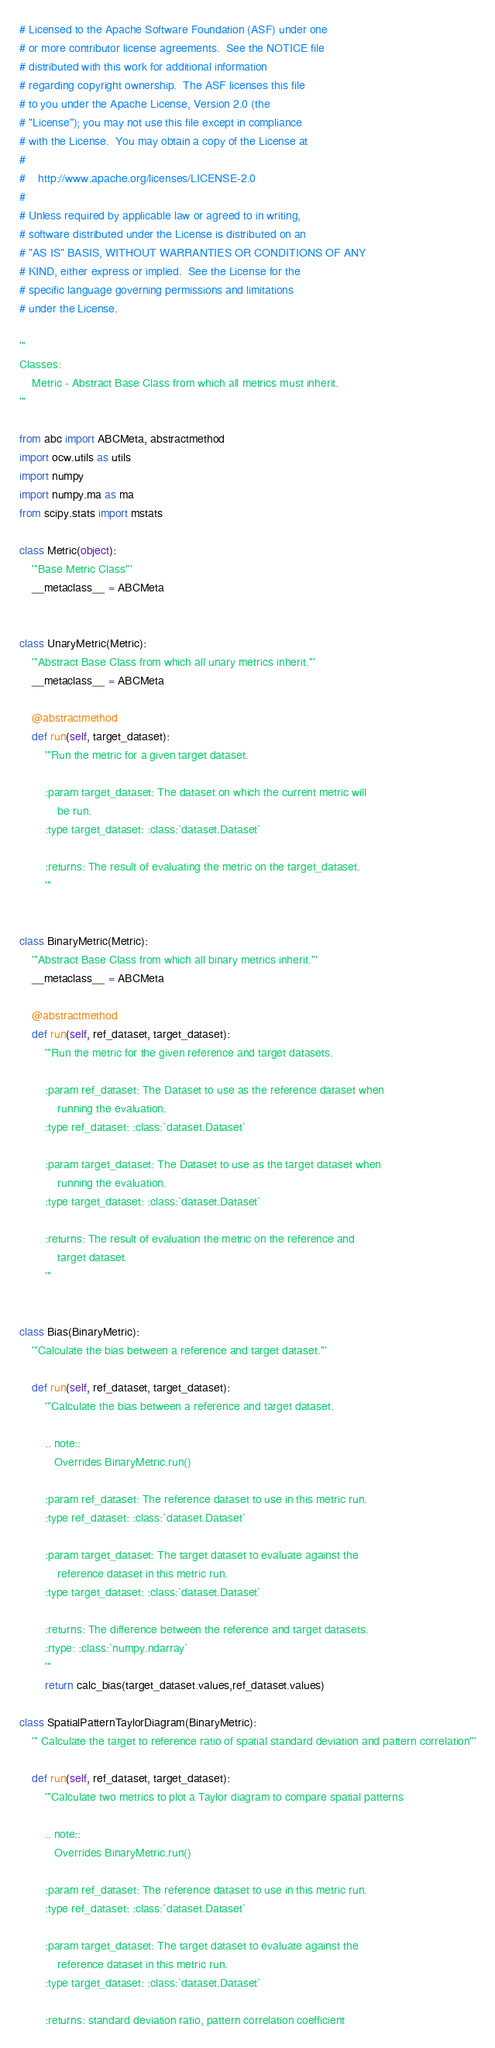Convert code to text. <code><loc_0><loc_0><loc_500><loc_500><_Python_># Licensed to the Apache Software Foundation (ASF) under one
# or more contributor license agreements.  See the NOTICE file
# distributed with this work for additional information
# regarding copyright ownership.  The ASF licenses this file
# to you under the Apache License, Version 2.0 (the
# "License"); you may not use this file except in compliance
# with the License.  You may obtain a copy of the License at
#
#    http://www.apache.org/licenses/LICENSE-2.0
#
# Unless required by applicable law or agreed to in writing,
# software distributed under the License is distributed on an
# "AS IS" BASIS, WITHOUT WARRANTIES OR CONDITIONS OF ANY
# KIND, either express or implied.  See the License for the
# specific language governing permissions and limitations
# under the License.

'''
Classes:
    Metric - Abstract Base Class from which all metrics must inherit.
'''

from abc import ABCMeta, abstractmethod
import ocw.utils as utils
import numpy
import numpy.ma as ma
from scipy.stats import mstats

class Metric(object):
    '''Base Metric Class'''
    __metaclass__ = ABCMeta


class UnaryMetric(Metric):
    '''Abstract Base Class from which all unary metrics inherit.'''
    __metaclass__ = ABCMeta

    @abstractmethod
    def run(self, target_dataset):
        '''Run the metric for a given target dataset.

        :param target_dataset: The dataset on which the current metric will
            be run.
        :type target_dataset: :class:`dataset.Dataset`

        :returns: The result of evaluating the metric on the target_dataset.
        '''


class BinaryMetric(Metric):
    '''Abstract Base Class from which all binary metrics inherit.'''
    __metaclass__ = ABCMeta

    @abstractmethod
    def run(self, ref_dataset, target_dataset):
        '''Run the metric for the given reference and target datasets.

        :param ref_dataset: The Dataset to use as the reference dataset when
            running the evaluation.
        :type ref_dataset: :class:`dataset.Dataset`

        :param target_dataset: The Dataset to use as the target dataset when
            running the evaluation.
        :type target_dataset: :class:`dataset.Dataset`

        :returns: The result of evaluation the metric on the reference and 
            target dataset.
        '''


class Bias(BinaryMetric):
    '''Calculate the bias between a reference and target dataset.'''

    def run(self, ref_dataset, target_dataset):
        '''Calculate the bias between a reference and target dataset.

        .. note::
           Overrides BinaryMetric.run()

        :param ref_dataset: The reference dataset to use in this metric run.
        :type ref_dataset: :class:`dataset.Dataset`

        :param target_dataset: The target dataset to evaluate against the
            reference dataset in this metric run.
        :type target_dataset: :class:`dataset.Dataset`

        :returns: The difference between the reference and target datasets.
        :rtype: :class:`numpy.ndarray`
        '''
        return calc_bias(target_dataset.values,ref_dataset.values) 

class SpatialPatternTaylorDiagram(BinaryMetric):
    ''' Calculate the target to reference ratio of spatial standard deviation and pattern correlation'''

    def run(self, ref_dataset, target_dataset):
        '''Calculate two metrics to plot a Taylor diagram to compare spatial patterns      

        .. note::
           Overrides BinaryMetric.run() 
        
        :param ref_dataset: The reference dataset to use in this metric run.
        :type ref_dataset: :class:`dataset.Dataset`

        :param target_dataset: The target dataset to evaluate against the
            reference dataset in this metric run.
        :type target_dataset: :class:`dataset.Dataset`

        :returns: standard deviation ratio, pattern correlation coefficient</code> 